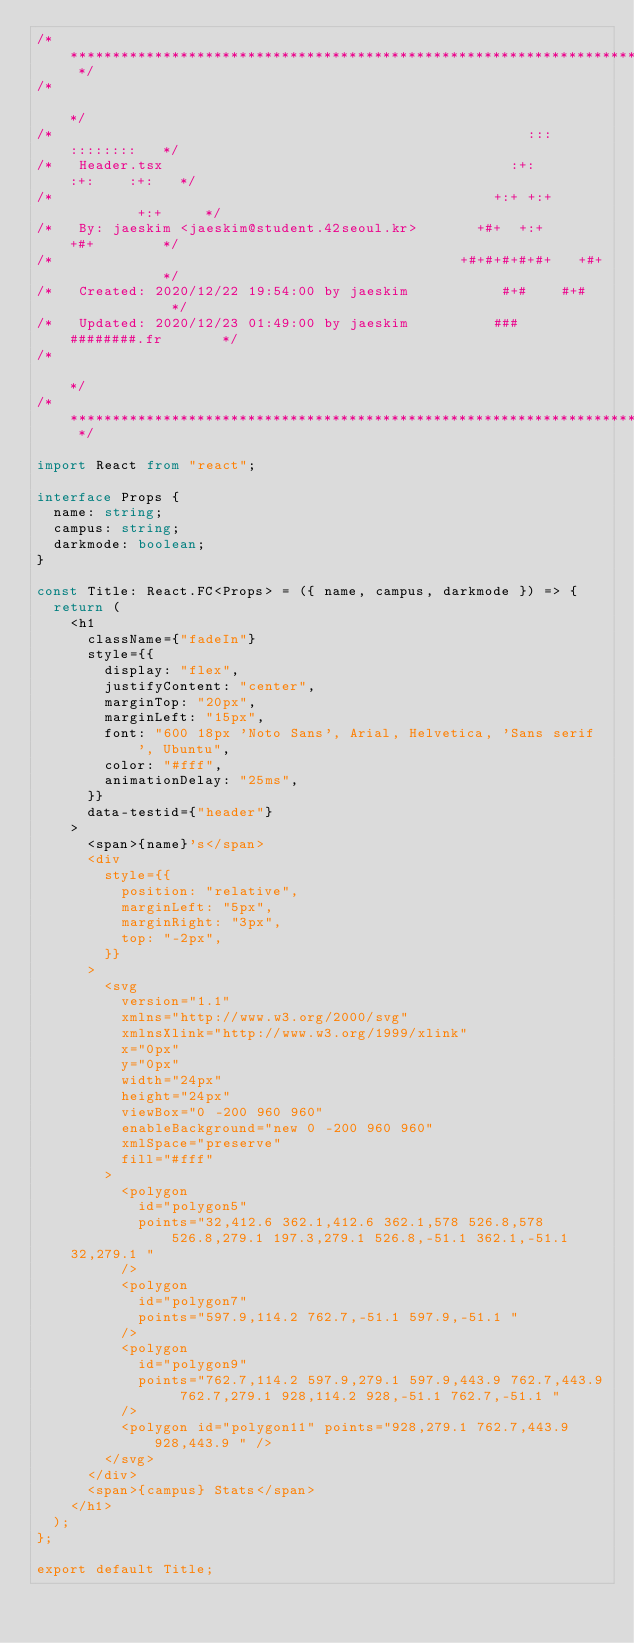Convert code to text. <code><loc_0><loc_0><loc_500><loc_500><_TypeScript_>/* ************************************************************************** */
/*                                                                            */
/*                                                        :::      ::::::::   */
/*   Header.tsx                                         :+:      :+:    :+:   */
/*                                                    +:+ +:+         +:+     */
/*   By: jaeskim <jaeskim@student.42seoul.kr>       +#+  +:+       +#+        */
/*                                                +#+#+#+#+#+   +#+           */
/*   Created: 2020/12/22 19:54:00 by jaeskim           #+#    #+#             */
/*   Updated: 2020/12/23 01:49:00 by jaeskim          ###   ########.fr       */
/*                                                                            */
/* ************************************************************************** */

import React from "react";

interface Props {
  name: string;
  campus: string;
  darkmode: boolean;
}

const Title: React.FC<Props> = ({ name, campus, darkmode }) => {
  return (
    <h1
      className={"fadeIn"}
      style={{
        display: "flex",
        justifyContent: "center",
        marginTop: "20px",
        marginLeft: "15px",
        font: "600 18px 'Noto Sans', Arial, Helvetica, 'Sans serif', Ubuntu",
        color: "#fff",
        animationDelay: "25ms",
      }}
      data-testid={"header"}
    >
      <span>{name}'s</span>
      <div
        style={{
          position: "relative",
          marginLeft: "5px",
          marginRight: "3px",
          top: "-2px",
        }}
      >
        <svg
          version="1.1"
          xmlns="http://www.w3.org/2000/svg"
          xmlnsXlink="http://www.w3.org/1999/xlink"
          x="0px"
          y="0px"
          width="24px"
          height="24px"
          viewBox="0 -200 960 960"
          enableBackground="new 0 -200 960 960"
          xmlSpace="preserve"
          fill="#fff"
        >
          <polygon
            id="polygon5"
            points="32,412.6 362.1,412.6 362.1,578 526.8,578 526.8,279.1 197.3,279.1 526.8,-51.1 362.1,-51.1
	32,279.1 "
          />
          <polygon
            id="polygon7"
            points="597.9,114.2 762.7,-51.1 597.9,-51.1 "
          />
          <polygon
            id="polygon9"
            points="762.7,114.2 597.9,279.1 597.9,443.9 762.7,443.9 762.7,279.1 928,114.2 928,-51.1 762.7,-51.1 "
          />
          <polygon id="polygon11" points="928,279.1 762.7,443.9 928,443.9 " />
        </svg>
      </div>
      <span>{campus} Stats</span>
    </h1>
  );
};

export default Title;
</code> 